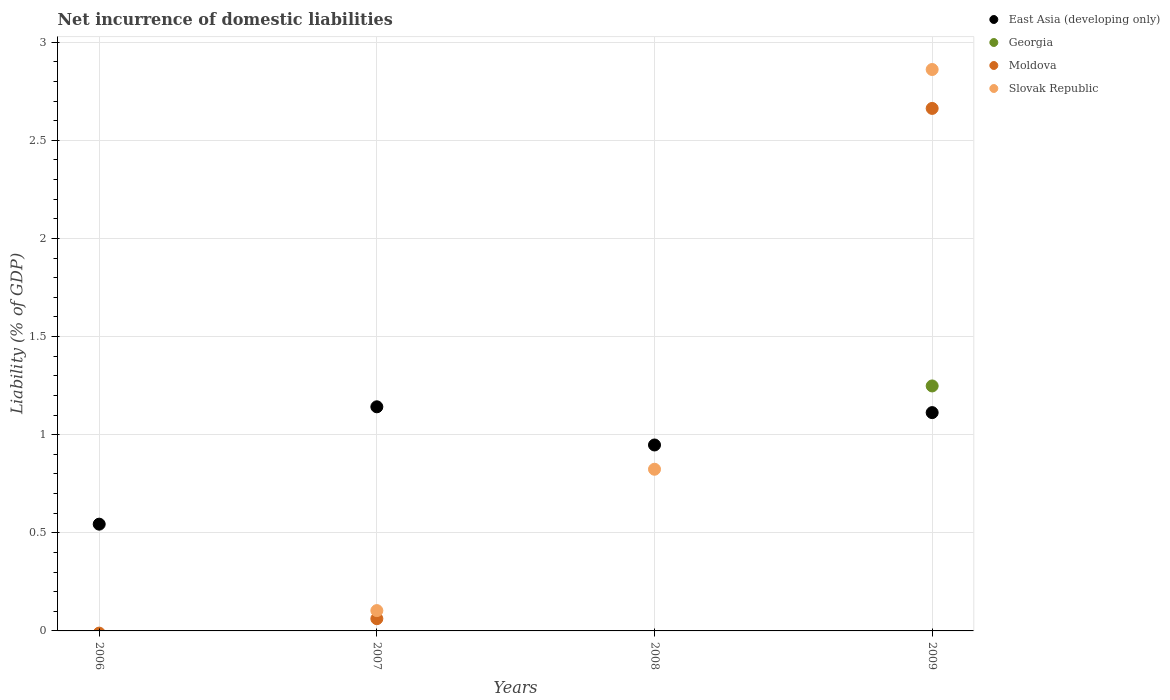Across all years, what is the maximum net incurrence of domestic liabilities in Slovak Republic?
Offer a very short reply. 2.86. Across all years, what is the minimum net incurrence of domestic liabilities in East Asia (developing only)?
Give a very brief answer. 0.54. What is the total net incurrence of domestic liabilities in Moldova in the graph?
Your answer should be very brief. 2.72. What is the difference between the net incurrence of domestic liabilities in East Asia (developing only) in 2006 and that in 2007?
Keep it short and to the point. -0.6. What is the difference between the net incurrence of domestic liabilities in East Asia (developing only) in 2007 and the net incurrence of domestic liabilities in Moldova in 2008?
Give a very brief answer. 1.14. What is the average net incurrence of domestic liabilities in Moldova per year?
Your answer should be compact. 0.68. In the year 2008, what is the difference between the net incurrence of domestic liabilities in East Asia (developing only) and net incurrence of domestic liabilities in Slovak Republic?
Give a very brief answer. 0.12. What is the ratio of the net incurrence of domestic liabilities in East Asia (developing only) in 2006 to that in 2007?
Give a very brief answer. 0.48. What is the difference between the highest and the second highest net incurrence of domestic liabilities in East Asia (developing only)?
Keep it short and to the point. 0.03. What is the difference between the highest and the lowest net incurrence of domestic liabilities in Georgia?
Provide a succinct answer. 1.25. In how many years, is the net incurrence of domestic liabilities in East Asia (developing only) greater than the average net incurrence of domestic liabilities in East Asia (developing only) taken over all years?
Keep it short and to the point. 3. Is the sum of the net incurrence of domestic liabilities in East Asia (developing only) in 2008 and 2009 greater than the maximum net incurrence of domestic liabilities in Moldova across all years?
Make the answer very short. No. Is it the case that in every year, the sum of the net incurrence of domestic liabilities in Slovak Republic and net incurrence of domestic liabilities in Georgia  is greater than the sum of net incurrence of domestic liabilities in East Asia (developing only) and net incurrence of domestic liabilities in Moldova?
Ensure brevity in your answer.  No. Is it the case that in every year, the sum of the net incurrence of domestic liabilities in Slovak Republic and net incurrence of domestic liabilities in Moldova  is greater than the net incurrence of domestic liabilities in Georgia?
Offer a terse response. No. Is the net incurrence of domestic liabilities in East Asia (developing only) strictly greater than the net incurrence of domestic liabilities in Moldova over the years?
Your answer should be very brief. No. Is the net incurrence of domestic liabilities in Moldova strictly less than the net incurrence of domestic liabilities in Georgia over the years?
Offer a terse response. No. Are the values on the major ticks of Y-axis written in scientific E-notation?
Keep it short and to the point. No. Does the graph contain any zero values?
Keep it short and to the point. Yes. Does the graph contain grids?
Provide a succinct answer. Yes. Where does the legend appear in the graph?
Your answer should be compact. Top right. How many legend labels are there?
Provide a succinct answer. 4. How are the legend labels stacked?
Give a very brief answer. Vertical. What is the title of the graph?
Provide a short and direct response. Net incurrence of domestic liabilities. Does "Kosovo" appear as one of the legend labels in the graph?
Provide a short and direct response. No. What is the label or title of the Y-axis?
Make the answer very short. Liability (% of GDP). What is the Liability (% of GDP) of East Asia (developing only) in 2006?
Keep it short and to the point. 0.54. What is the Liability (% of GDP) in Slovak Republic in 2006?
Your response must be concise. 0. What is the Liability (% of GDP) of East Asia (developing only) in 2007?
Provide a short and direct response. 1.14. What is the Liability (% of GDP) in Georgia in 2007?
Make the answer very short. 0. What is the Liability (% of GDP) of Moldova in 2007?
Your answer should be compact. 0.06. What is the Liability (% of GDP) of Slovak Republic in 2007?
Your answer should be very brief. 0.1. What is the Liability (% of GDP) of East Asia (developing only) in 2008?
Your response must be concise. 0.95. What is the Liability (% of GDP) in Moldova in 2008?
Provide a succinct answer. 0. What is the Liability (% of GDP) in Slovak Republic in 2008?
Provide a succinct answer. 0.82. What is the Liability (% of GDP) of East Asia (developing only) in 2009?
Provide a short and direct response. 1.11. What is the Liability (% of GDP) in Georgia in 2009?
Ensure brevity in your answer.  1.25. What is the Liability (% of GDP) of Moldova in 2009?
Ensure brevity in your answer.  2.66. What is the Liability (% of GDP) in Slovak Republic in 2009?
Offer a terse response. 2.86. Across all years, what is the maximum Liability (% of GDP) in East Asia (developing only)?
Ensure brevity in your answer.  1.14. Across all years, what is the maximum Liability (% of GDP) of Georgia?
Make the answer very short. 1.25. Across all years, what is the maximum Liability (% of GDP) of Moldova?
Keep it short and to the point. 2.66. Across all years, what is the maximum Liability (% of GDP) in Slovak Republic?
Your response must be concise. 2.86. Across all years, what is the minimum Liability (% of GDP) of East Asia (developing only)?
Provide a succinct answer. 0.54. Across all years, what is the minimum Liability (% of GDP) in Georgia?
Offer a very short reply. 0. Across all years, what is the minimum Liability (% of GDP) in Slovak Republic?
Offer a terse response. 0. What is the total Liability (% of GDP) in East Asia (developing only) in the graph?
Your answer should be very brief. 3.75. What is the total Liability (% of GDP) of Georgia in the graph?
Provide a short and direct response. 1.25. What is the total Liability (% of GDP) in Moldova in the graph?
Provide a short and direct response. 2.72. What is the total Liability (% of GDP) in Slovak Republic in the graph?
Offer a very short reply. 3.79. What is the difference between the Liability (% of GDP) of East Asia (developing only) in 2006 and that in 2007?
Offer a terse response. -0.6. What is the difference between the Liability (% of GDP) in East Asia (developing only) in 2006 and that in 2008?
Keep it short and to the point. -0.4. What is the difference between the Liability (% of GDP) of East Asia (developing only) in 2006 and that in 2009?
Your answer should be very brief. -0.57. What is the difference between the Liability (% of GDP) in East Asia (developing only) in 2007 and that in 2008?
Offer a very short reply. 0.19. What is the difference between the Liability (% of GDP) of Slovak Republic in 2007 and that in 2008?
Your answer should be compact. -0.72. What is the difference between the Liability (% of GDP) of East Asia (developing only) in 2007 and that in 2009?
Offer a very short reply. 0.03. What is the difference between the Liability (% of GDP) in Moldova in 2007 and that in 2009?
Make the answer very short. -2.6. What is the difference between the Liability (% of GDP) of Slovak Republic in 2007 and that in 2009?
Your answer should be very brief. -2.76. What is the difference between the Liability (% of GDP) of East Asia (developing only) in 2008 and that in 2009?
Provide a short and direct response. -0.16. What is the difference between the Liability (% of GDP) of Slovak Republic in 2008 and that in 2009?
Your response must be concise. -2.04. What is the difference between the Liability (% of GDP) of East Asia (developing only) in 2006 and the Liability (% of GDP) of Moldova in 2007?
Offer a very short reply. 0.48. What is the difference between the Liability (% of GDP) of East Asia (developing only) in 2006 and the Liability (% of GDP) of Slovak Republic in 2007?
Ensure brevity in your answer.  0.44. What is the difference between the Liability (% of GDP) of East Asia (developing only) in 2006 and the Liability (% of GDP) of Slovak Republic in 2008?
Ensure brevity in your answer.  -0.28. What is the difference between the Liability (% of GDP) of East Asia (developing only) in 2006 and the Liability (% of GDP) of Georgia in 2009?
Your response must be concise. -0.7. What is the difference between the Liability (% of GDP) in East Asia (developing only) in 2006 and the Liability (% of GDP) in Moldova in 2009?
Provide a succinct answer. -2.12. What is the difference between the Liability (% of GDP) of East Asia (developing only) in 2006 and the Liability (% of GDP) of Slovak Republic in 2009?
Provide a succinct answer. -2.32. What is the difference between the Liability (% of GDP) in East Asia (developing only) in 2007 and the Liability (% of GDP) in Slovak Republic in 2008?
Your answer should be very brief. 0.32. What is the difference between the Liability (% of GDP) in Moldova in 2007 and the Liability (% of GDP) in Slovak Republic in 2008?
Your answer should be compact. -0.76. What is the difference between the Liability (% of GDP) of East Asia (developing only) in 2007 and the Liability (% of GDP) of Georgia in 2009?
Your answer should be very brief. -0.11. What is the difference between the Liability (% of GDP) of East Asia (developing only) in 2007 and the Liability (% of GDP) of Moldova in 2009?
Offer a terse response. -1.52. What is the difference between the Liability (% of GDP) of East Asia (developing only) in 2007 and the Liability (% of GDP) of Slovak Republic in 2009?
Keep it short and to the point. -1.72. What is the difference between the Liability (% of GDP) of Moldova in 2007 and the Liability (% of GDP) of Slovak Republic in 2009?
Offer a terse response. -2.8. What is the difference between the Liability (% of GDP) in East Asia (developing only) in 2008 and the Liability (% of GDP) in Georgia in 2009?
Provide a succinct answer. -0.3. What is the difference between the Liability (% of GDP) in East Asia (developing only) in 2008 and the Liability (% of GDP) in Moldova in 2009?
Give a very brief answer. -1.71. What is the difference between the Liability (% of GDP) of East Asia (developing only) in 2008 and the Liability (% of GDP) of Slovak Republic in 2009?
Provide a short and direct response. -1.91. What is the average Liability (% of GDP) of East Asia (developing only) per year?
Offer a terse response. 0.94. What is the average Liability (% of GDP) in Georgia per year?
Keep it short and to the point. 0.31. What is the average Liability (% of GDP) in Moldova per year?
Provide a short and direct response. 0.68. What is the average Liability (% of GDP) of Slovak Republic per year?
Offer a terse response. 0.95. In the year 2007, what is the difference between the Liability (% of GDP) in East Asia (developing only) and Liability (% of GDP) in Moldova?
Offer a very short reply. 1.08. In the year 2007, what is the difference between the Liability (% of GDP) of East Asia (developing only) and Liability (% of GDP) of Slovak Republic?
Provide a short and direct response. 1.04. In the year 2007, what is the difference between the Liability (% of GDP) in Moldova and Liability (% of GDP) in Slovak Republic?
Keep it short and to the point. -0.04. In the year 2008, what is the difference between the Liability (% of GDP) of East Asia (developing only) and Liability (% of GDP) of Slovak Republic?
Offer a very short reply. 0.12. In the year 2009, what is the difference between the Liability (% of GDP) of East Asia (developing only) and Liability (% of GDP) of Georgia?
Your answer should be compact. -0.14. In the year 2009, what is the difference between the Liability (% of GDP) of East Asia (developing only) and Liability (% of GDP) of Moldova?
Ensure brevity in your answer.  -1.55. In the year 2009, what is the difference between the Liability (% of GDP) of East Asia (developing only) and Liability (% of GDP) of Slovak Republic?
Provide a succinct answer. -1.75. In the year 2009, what is the difference between the Liability (% of GDP) in Georgia and Liability (% of GDP) in Moldova?
Offer a terse response. -1.41. In the year 2009, what is the difference between the Liability (% of GDP) in Georgia and Liability (% of GDP) in Slovak Republic?
Provide a succinct answer. -1.61. In the year 2009, what is the difference between the Liability (% of GDP) in Moldova and Liability (% of GDP) in Slovak Republic?
Ensure brevity in your answer.  -0.2. What is the ratio of the Liability (% of GDP) of East Asia (developing only) in 2006 to that in 2007?
Your answer should be compact. 0.48. What is the ratio of the Liability (% of GDP) of East Asia (developing only) in 2006 to that in 2008?
Provide a succinct answer. 0.57. What is the ratio of the Liability (% of GDP) in East Asia (developing only) in 2006 to that in 2009?
Your response must be concise. 0.49. What is the ratio of the Liability (% of GDP) of East Asia (developing only) in 2007 to that in 2008?
Offer a very short reply. 1.21. What is the ratio of the Liability (% of GDP) in Slovak Republic in 2007 to that in 2008?
Make the answer very short. 0.13. What is the ratio of the Liability (% of GDP) of East Asia (developing only) in 2007 to that in 2009?
Provide a succinct answer. 1.03. What is the ratio of the Liability (% of GDP) of Moldova in 2007 to that in 2009?
Keep it short and to the point. 0.02. What is the ratio of the Liability (% of GDP) of Slovak Republic in 2007 to that in 2009?
Your answer should be very brief. 0.04. What is the ratio of the Liability (% of GDP) in East Asia (developing only) in 2008 to that in 2009?
Keep it short and to the point. 0.85. What is the ratio of the Liability (% of GDP) of Slovak Republic in 2008 to that in 2009?
Ensure brevity in your answer.  0.29. What is the difference between the highest and the second highest Liability (% of GDP) in East Asia (developing only)?
Offer a terse response. 0.03. What is the difference between the highest and the second highest Liability (% of GDP) of Slovak Republic?
Provide a short and direct response. 2.04. What is the difference between the highest and the lowest Liability (% of GDP) of East Asia (developing only)?
Your answer should be very brief. 0.6. What is the difference between the highest and the lowest Liability (% of GDP) in Georgia?
Offer a terse response. 1.25. What is the difference between the highest and the lowest Liability (% of GDP) in Moldova?
Keep it short and to the point. 2.66. What is the difference between the highest and the lowest Liability (% of GDP) in Slovak Republic?
Give a very brief answer. 2.86. 